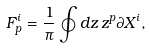<formula> <loc_0><loc_0><loc_500><loc_500>F _ { p } ^ { i } = { \frac { 1 } { \pi } } \oint d z \, z ^ { p } \partial X ^ { i } ,</formula> 